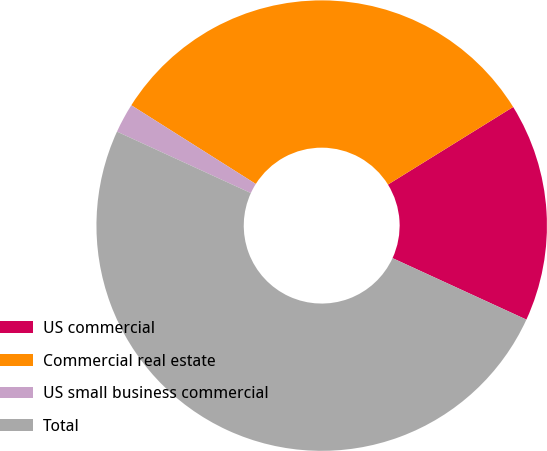Convert chart to OTSL. <chart><loc_0><loc_0><loc_500><loc_500><pie_chart><fcel>US commercial<fcel>Commercial real estate<fcel>US small business commercial<fcel>Total<nl><fcel>15.68%<fcel>32.2%<fcel>2.12%<fcel>50.0%<nl></chart> 